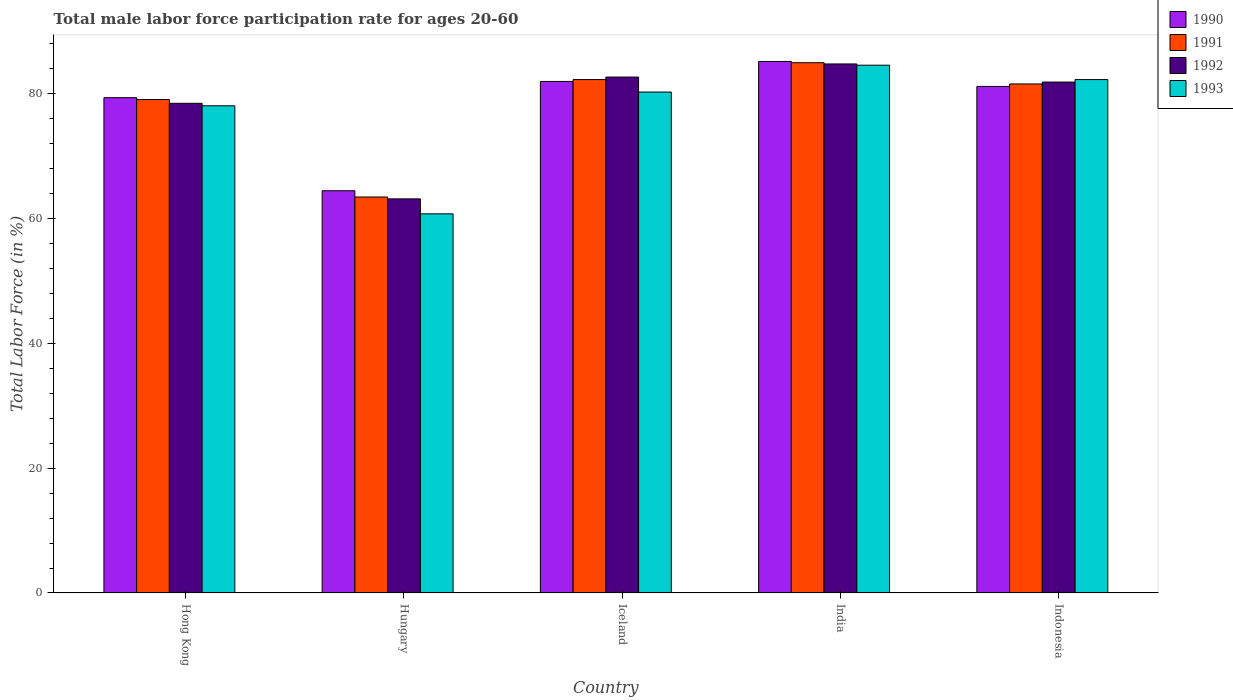How many groups of bars are there?
Keep it short and to the point. 5. Are the number of bars on each tick of the X-axis equal?
Keep it short and to the point. Yes. What is the label of the 3rd group of bars from the left?
Offer a terse response. Iceland. In how many cases, is the number of bars for a given country not equal to the number of legend labels?
Offer a very short reply. 0. What is the male labor force participation rate in 1992 in Hong Kong?
Offer a very short reply. 78.4. Across all countries, what is the maximum male labor force participation rate in 1993?
Make the answer very short. 84.5. Across all countries, what is the minimum male labor force participation rate in 1991?
Offer a very short reply. 63.4. In which country was the male labor force participation rate in 1992 maximum?
Your response must be concise. India. In which country was the male labor force participation rate in 1993 minimum?
Offer a terse response. Hungary. What is the total male labor force participation rate in 1990 in the graph?
Keep it short and to the point. 391.8. What is the difference between the male labor force participation rate in 1991 in Hungary and that in Indonesia?
Provide a short and direct response. -18.1. What is the difference between the male labor force participation rate in 1990 in India and the male labor force participation rate in 1991 in Indonesia?
Provide a short and direct response. 3.6. What is the average male labor force participation rate in 1991 per country?
Make the answer very short. 78.2. What is the difference between the male labor force participation rate of/in 1991 and male labor force participation rate of/in 1993 in Indonesia?
Keep it short and to the point. -0.7. In how many countries, is the male labor force participation rate in 1990 greater than 80 %?
Your answer should be compact. 3. What is the ratio of the male labor force participation rate in 1993 in India to that in Indonesia?
Offer a terse response. 1.03. Is the male labor force participation rate in 1991 in Hungary less than that in Indonesia?
Your answer should be compact. Yes. Is the difference between the male labor force participation rate in 1991 in Hong Kong and Indonesia greater than the difference between the male labor force participation rate in 1993 in Hong Kong and Indonesia?
Your answer should be compact. Yes. What is the difference between the highest and the second highest male labor force participation rate in 1992?
Provide a short and direct response. -0.8. What is the difference between the highest and the lowest male labor force participation rate in 1992?
Give a very brief answer. 21.6. Is the sum of the male labor force participation rate in 1991 in India and Indonesia greater than the maximum male labor force participation rate in 1992 across all countries?
Make the answer very short. Yes. What does the 4th bar from the left in Iceland represents?
Provide a short and direct response. 1993. What does the 4th bar from the right in Hong Kong represents?
Your response must be concise. 1990. Is it the case that in every country, the sum of the male labor force participation rate in 1991 and male labor force participation rate in 1993 is greater than the male labor force participation rate in 1990?
Your answer should be very brief. Yes. How many bars are there?
Your response must be concise. 20. Are the values on the major ticks of Y-axis written in scientific E-notation?
Offer a very short reply. No. Does the graph contain any zero values?
Your answer should be very brief. No. Does the graph contain grids?
Keep it short and to the point. No. How are the legend labels stacked?
Keep it short and to the point. Vertical. What is the title of the graph?
Your response must be concise. Total male labor force participation rate for ages 20-60. Does "1983" appear as one of the legend labels in the graph?
Your answer should be compact. No. What is the Total Labor Force (in %) of 1990 in Hong Kong?
Offer a terse response. 79.3. What is the Total Labor Force (in %) of 1991 in Hong Kong?
Ensure brevity in your answer.  79. What is the Total Labor Force (in %) in 1992 in Hong Kong?
Give a very brief answer. 78.4. What is the Total Labor Force (in %) in 1990 in Hungary?
Ensure brevity in your answer.  64.4. What is the Total Labor Force (in %) in 1991 in Hungary?
Make the answer very short. 63.4. What is the Total Labor Force (in %) of 1992 in Hungary?
Provide a succinct answer. 63.1. What is the Total Labor Force (in %) of 1993 in Hungary?
Provide a succinct answer. 60.7. What is the Total Labor Force (in %) in 1990 in Iceland?
Your answer should be very brief. 81.9. What is the Total Labor Force (in %) of 1991 in Iceland?
Make the answer very short. 82.2. What is the Total Labor Force (in %) in 1992 in Iceland?
Ensure brevity in your answer.  82.6. What is the Total Labor Force (in %) in 1993 in Iceland?
Offer a terse response. 80.2. What is the Total Labor Force (in %) in 1990 in India?
Keep it short and to the point. 85.1. What is the Total Labor Force (in %) of 1991 in India?
Provide a succinct answer. 84.9. What is the Total Labor Force (in %) in 1992 in India?
Ensure brevity in your answer.  84.7. What is the Total Labor Force (in %) of 1993 in India?
Your response must be concise. 84.5. What is the Total Labor Force (in %) of 1990 in Indonesia?
Your response must be concise. 81.1. What is the Total Labor Force (in %) of 1991 in Indonesia?
Give a very brief answer. 81.5. What is the Total Labor Force (in %) in 1992 in Indonesia?
Make the answer very short. 81.8. What is the Total Labor Force (in %) of 1993 in Indonesia?
Offer a very short reply. 82.2. Across all countries, what is the maximum Total Labor Force (in %) in 1990?
Provide a short and direct response. 85.1. Across all countries, what is the maximum Total Labor Force (in %) of 1991?
Give a very brief answer. 84.9. Across all countries, what is the maximum Total Labor Force (in %) of 1992?
Your response must be concise. 84.7. Across all countries, what is the maximum Total Labor Force (in %) in 1993?
Your answer should be compact. 84.5. Across all countries, what is the minimum Total Labor Force (in %) in 1990?
Make the answer very short. 64.4. Across all countries, what is the minimum Total Labor Force (in %) in 1991?
Your response must be concise. 63.4. Across all countries, what is the minimum Total Labor Force (in %) in 1992?
Provide a short and direct response. 63.1. Across all countries, what is the minimum Total Labor Force (in %) in 1993?
Make the answer very short. 60.7. What is the total Total Labor Force (in %) in 1990 in the graph?
Your response must be concise. 391.8. What is the total Total Labor Force (in %) in 1991 in the graph?
Provide a succinct answer. 391. What is the total Total Labor Force (in %) of 1992 in the graph?
Give a very brief answer. 390.6. What is the total Total Labor Force (in %) in 1993 in the graph?
Your response must be concise. 385.6. What is the difference between the Total Labor Force (in %) in 1990 in Hong Kong and that in Hungary?
Ensure brevity in your answer.  14.9. What is the difference between the Total Labor Force (in %) in 1992 in Hong Kong and that in Hungary?
Offer a terse response. 15.3. What is the difference between the Total Labor Force (in %) of 1991 in Hong Kong and that in Iceland?
Offer a terse response. -3.2. What is the difference between the Total Labor Force (in %) of 1992 in Hong Kong and that in Iceland?
Your answer should be compact. -4.2. What is the difference between the Total Labor Force (in %) in 1993 in Hong Kong and that in Iceland?
Your answer should be very brief. -2.2. What is the difference between the Total Labor Force (in %) of 1993 in Hong Kong and that in India?
Make the answer very short. -6.5. What is the difference between the Total Labor Force (in %) of 1990 in Hong Kong and that in Indonesia?
Offer a very short reply. -1.8. What is the difference between the Total Labor Force (in %) of 1992 in Hong Kong and that in Indonesia?
Keep it short and to the point. -3.4. What is the difference between the Total Labor Force (in %) in 1990 in Hungary and that in Iceland?
Your answer should be compact. -17.5. What is the difference between the Total Labor Force (in %) of 1991 in Hungary and that in Iceland?
Offer a terse response. -18.8. What is the difference between the Total Labor Force (in %) of 1992 in Hungary and that in Iceland?
Your answer should be very brief. -19.5. What is the difference between the Total Labor Force (in %) in 1993 in Hungary and that in Iceland?
Provide a short and direct response. -19.5. What is the difference between the Total Labor Force (in %) in 1990 in Hungary and that in India?
Your answer should be very brief. -20.7. What is the difference between the Total Labor Force (in %) of 1991 in Hungary and that in India?
Your answer should be compact. -21.5. What is the difference between the Total Labor Force (in %) of 1992 in Hungary and that in India?
Keep it short and to the point. -21.6. What is the difference between the Total Labor Force (in %) of 1993 in Hungary and that in India?
Your answer should be very brief. -23.8. What is the difference between the Total Labor Force (in %) of 1990 in Hungary and that in Indonesia?
Provide a succinct answer. -16.7. What is the difference between the Total Labor Force (in %) in 1991 in Hungary and that in Indonesia?
Provide a succinct answer. -18.1. What is the difference between the Total Labor Force (in %) of 1992 in Hungary and that in Indonesia?
Your answer should be compact. -18.7. What is the difference between the Total Labor Force (in %) of 1993 in Hungary and that in Indonesia?
Make the answer very short. -21.5. What is the difference between the Total Labor Force (in %) of 1991 in Iceland and that in India?
Your answer should be very brief. -2.7. What is the difference between the Total Labor Force (in %) of 1993 in Iceland and that in India?
Ensure brevity in your answer.  -4.3. What is the difference between the Total Labor Force (in %) in 1990 in Iceland and that in Indonesia?
Provide a succinct answer. 0.8. What is the difference between the Total Labor Force (in %) of 1992 in Iceland and that in Indonesia?
Ensure brevity in your answer.  0.8. What is the difference between the Total Labor Force (in %) in 1991 in India and that in Indonesia?
Your answer should be compact. 3.4. What is the difference between the Total Labor Force (in %) in 1992 in India and that in Indonesia?
Offer a very short reply. 2.9. What is the difference between the Total Labor Force (in %) in 1993 in India and that in Indonesia?
Your answer should be compact. 2.3. What is the difference between the Total Labor Force (in %) in 1990 in Hong Kong and the Total Labor Force (in %) in 1991 in Hungary?
Your answer should be very brief. 15.9. What is the difference between the Total Labor Force (in %) of 1990 in Hong Kong and the Total Labor Force (in %) of 1992 in Hungary?
Your response must be concise. 16.2. What is the difference between the Total Labor Force (in %) of 1990 in Hong Kong and the Total Labor Force (in %) of 1992 in Iceland?
Ensure brevity in your answer.  -3.3. What is the difference between the Total Labor Force (in %) in 1990 in Hong Kong and the Total Labor Force (in %) in 1993 in Iceland?
Make the answer very short. -0.9. What is the difference between the Total Labor Force (in %) of 1990 in Hong Kong and the Total Labor Force (in %) of 1991 in India?
Ensure brevity in your answer.  -5.6. What is the difference between the Total Labor Force (in %) of 1991 in Hong Kong and the Total Labor Force (in %) of 1992 in India?
Ensure brevity in your answer.  -5.7. What is the difference between the Total Labor Force (in %) in 1991 in Hong Kong and the Total Labor Force (in %) in 1993 in India?
Keep it short and to the point. -5.5. What is the difference between the Total Labor Force (in %) in 1990 in Hong Kong and the Total Labor Force (in %) in 1993 in Indonesia?
Your answer should be compact. -2.9. What is the difference between the Total Labor Force (in %) in 1990 in Hungary and the Total Labor Force (in %) in 1991 in Iceland?
Offer a very short reply. -17.8. What is the difference between the Total Labor Force (in %) of 1990 in Hungary and the Total Labor Force (in %) of 1992 in Iceland?
Your answer should be compact. -18.2. What is the difference between the Total Labor Force (in %) of 1990 in Hungary and the Total Labor Force (in %) of 1993 in Iceland?
Ensure brevity in your answer.  -15.8. What is the difference between the Total Labor Force (in %) in 1991 in Hungary and the Total Labor Force (in %) in 1992 in Iceland?
Ensure brevity in your answer.  -19.2. What is the difference between the Total Labor Force (in %) of 1991 in Hungary and the Total Labor Force (in %) of 1993 in Iceland?
Provide a succinct answer. -16.8. What is the difference between the Total Labor Force (in %) in 1992 in Hungary and the Total Labor Force (in %) in 1993 in Iceland?
Offer a very short reply. -17.1. What is the difference between the Total Labor Force (in %) of 1990 in Hungary and the Total Labor Force (in %) of 1991 in India?
Your response must be concise. -20.5. What is the difference between the Total Labor Force (in %) in 1990 in Hungary and the Total Labor Force (in %) in 1992 in India?
Make the answer very short. -20.3. What is the difference between the Total Labor Force (in %) of 1990 in Hungary and the Total Labor Force (in %) of 1993 in India?
Keep it short and to the point. -20.1. What is the difference between the Total Labor Force (in %) in 1991 in Hungary and the Total Labor Force (in %) in 1992 in India?
Offer a terse response. -21.3. What is the difference between the Total Labor Force (in %) in 1991 in Hungary and the Total Labor Force (in %) in 1993 in India?
Ensure brevity in your answer.  -21.1. What is the difference between the Total Labor Force (in %) in 1992 in Hungary and the Total Labor Force (in %) in 1993 in India?
Make the answer very short. -21.4. What is the difference between the Total Labor Force (in %) of 1990 in Hungary and the Total Labor Force (in %) of 1991 in Indonesia?
Give a very brief answer. -17.1. What is the difference between the Total Labor Force (in %) of 1990 in Hungary and the Total Labor Force (in %) of 1992 in Indonesia?
Keep it short and to the point. -17.4. What is the difference between the Total Labor Force (in %) of 1990 in Hungary and the Total Labor Force (in %) of 1993 in Indonesia?
Ensure brevity in your answer.  -17.8. What is the difference between the Total Labor Force (in %) of 1991 in Hungary and the Total Labor Force (in %) of 1992 in Indonesia?
Give a very brief answer. -18.4. What is the difference between the Total Labor Force (in %) of 1991 in Hungary and the Total Labor Force (in %) of 1993 in Indonesia?
Keep it short and to the point. -18.8. What is the difference between the Total Labor Force (in %) of 1992 in Hungary and the Total Labor Force (in %) of 1993 in Indonesia?
Ensure brevity in your answer.  -19.1. What is the difference between the Total Labor Force (in %) of 1990 in Iceland and the Total Labor Force (in %) of 1991 in India?
Provide a short and direct response. -3. What is the difference between the Total Labor Force (in %) in 1990 in Iceland and the Total Labor Force (in %) in 1992 in India?
Offer a very short reply. -2.8. What is the difference between the Total Labor Force (in %) in 1990 in Iceland and the Total Labor Force (in %) in 1993 in India?
Ensure brevity in your answer.  -2.6. What is the difference between the Total Labor Force (in %) of 1991 in Iceland and the Total Labor Force (in %) of 1992 in India?
Offer a terse response. -2.5. What is the difference between the Total Labor Force (in %) of 1990 in Iceland and the Total Labor Force (in %) of 1991 in Indonesia?
Ensure brevity in your answer.  0.4. What is the difference between the Total Labor Force (in %) of 1990 in Iceland and the Total Labor Force (in %) of 1993 in Indonesia?
Make the answer very short. -0.3. What is the difference between the Total Labor Force (in %) in 1991 in Iceland and the Total Labor Force (in %) in 1992 in Indonesia?
Give a very brief answer. 0.4. What is the difference between the Total Labor Force (in %) of 1991 in Iceland and the Total Labor Force (in %) of 1993 in Indonesia?
Provide a succinct answer. 0. What is the difference between the Total Labor Force (in %) in 1992 in Iceland and the Total Labor Force (in %) in 1993 in Indonesia?
Ensure brevity in your answer.  0.4. What is the difference between the Total Labor Force (in %) in 1990 in India and the Total Labor Force (in %) in 1991 in Indonesia?
Give a very brief answer. 3.6. What is the difference between the Total Labor Force (in %) of 1990 in India and the Total Labor Force (in %) of 1992 in Indonesia?
Give a very brief answer. 3.3. What is the difference between the Total Labor Force (in %) in 1991 in India and the Total Labor Force (in %) in 1993 in Indonesia?
Ensure brevity in your answer.  2.7. What is the difference between the Total Labor Force (in %) in 1992 in India and the Total Labor Force (in %) in 1993 in Indonesia?
Ensure brevity in your answer.  2.5. What is the average Total Labor Force (in %) of 1990 per country?
Offer a very short reply. 78.36. What is the average Total Labor Force (in %) in 1991 per country?
Keep it short and to the point. 78.2. What is the average Total Labor Force (in %) in 1992 per country?
Keep it short and to the point. 78.12. What is the average Total Labor Force (in %) in 1993 per country?
Keep it short and to the point. 77.12. What is the difference between the Total Labor Force (in %) of 1990 and Total Labor Force (in %) of 1992 in Hong Kong?
Your response must be concise. 0.9. What is the difference between the Total Labor Force (in %) in 1990 and Total Labor Force (in %) in 1993 in Hong Kong?
Your answer should be compact. 1.3. What is the difference between the Total Labor Force (in %) in 1991 and Total Labor Force (in %) in 1992 in Hong Kong?
Provide a succinct answer. 0.6. What is the difference between the Total Labor Force (in %) of 1990 and Total Labor Force (in %) of 1993 in Hungary?
Your answer should be very brief. 3.7. What is the difference between the Total Labor Force (in %) of 1991 and Total Labor Force (in %) of 1993 in Hungary?
Offer a terse response. 2.7. What is the difference between the Total Labor Force (in %) of 1990 and Total Labor Force (in %) of 1991 in Iceland?
Offer a terse response. -0.3. What is the difference between the Total Labor Force (in %) in 1990 and Total Labor Force (in %) in 1992 in Iceland?
Your response must be concise. -0.7. What is the difference between the Total Labor Force (in %) of 1990 and Total Labor Force (in %) of 1991 in India?
Keep it short and to the point. 0.2. What is the difference between the Total Labor Force (in %) in 1990 and Total Labor Force (in %) in 1992 in India?
Keep it short and to the point. 0.4. What is the difference between the Total Labor Force (in %) of 1991 and Total Labor Force (in %) of 1993 in India?
Your response must be concise. 0.4. What is the difference between the Total Labor Force (in %) in 1990 and Total Labor Force (in %) in 1991 in Indonesia?
Provide a succinct answer. -0.4. What is the difference between the Total Labor Force (in %) in 1992 and Total Labor Force (in %) in 1993 in Indonesia?
Your response must be concise. -0.4. What is the ratio of the Total Labor Force (in %) in 1990 in Hong Kong to that in Hungary?
Ensure brevity in your answer.  1.23. What is the ratio of the Total Labor Force (in %) in 1991 in Hong Kong to that in Hungary?
Provide a short and direct response. 1.25. What is the ratio of the Total Labor Force (in %) in 1992 in Hong Kong to that in Hungary?
Give a very brief answer. 1.24. What is the ratio of the Total Labor Force (in %) of 1993 in Hong Kong to that in Hungary?
Offer a very short reply. 1.28. What is the ratio of the Total Labor Force (in %) in 1990 in Hong Kong to that in Iceland?
Make the answer very short. 0.97. What is the ratio of the Total Labor Force (in %) in 1991 in Hong Kong to that in Iceland?
Keep it short and to the point. 0.96. What is the ratio of the Total Labor Force (in %) in 1992 in Hong Kong to that in Iceland?
Offer a terse response. 0.95. What is the ratio of the Total Labor Force (in %) in 1993 in Hong Kong to that in Iceland?
Offer a very short reply. 0.97. What is the ratio of the Total Labor Force (in %) of 1990 in Hong Kong to that in India?
Your answer should be compact. 0.93. What is the ratio of the Total Labor Force (in %) of 1991 in Hong Kong to that in India?
Offer a very short reply. 0.93. What is the ratio of the Total Labor Force (in %) of 1992 in Hong Kong to that in India?
Offer a terse response. 0.93. What is the ratio of the Total Labor Force (in %) in 1990 in Hong Kong to that in Indonesia?
Your answer should be very brief. 0.98. What is the ratio of the Total Labor Force (in %) of 1991 in Hong Kong to that in Indonesia?
Give a very brief answer. 0.97. What is the ratio of the Total Labor Force (in %) of 1992 in Hong Kong to that in Indonesia?
Offer a terse response. 0.96. What is the ratio of the Total Labor Force (in %) of 1993 in Hong Kong to that in Indonesia?
Offer a terse response. 0.95. What is the ratio of the Total Labor Force (in %) in 1990 in Hungary to that in Iceland?
Your answer should be compact. 0.79. What is the ratio of the Total Labor Force (in %) in 1991 in Hungary to that in Iceland?
Your response must be concise. 0.77. What is the ratio of the Total Labor Force (in %) in 1992 in Hungary to that in Iceland?
Provide a short and direct response. 0.76. What is the ratio of the Total Labor Force (in %) of 1993 in Hungary to that in Iceland?
Your answer should be very brief. 0.76. What is the ratio of the Total Labor Force (in %) in 1990 in Hungary to that in India?
Your answer should be very brief. 0.76. What is the ratio of the Total Labor Force (in %) in 1991 in Hungary to that in India?
Your answer should be very brief. 0.75. What is the ratio of the Total Labor Force (in %) of 1992 in Hungary to that in India?
Provide a short and direct response. 0.74. What is the ratio of the Total Labor Force (in %) in 1993 in Hungary to that in India?
Your answer should be compact. 0.72. What is the ratio of the Total Labor Force (in %) in 1990 in Hungary to that in Indonesia?
Offer a terse response. 0.79. What is the ratio of the Total Labor Force (in %) in 1991 in Hungary to that in Indonesia?
Your response must be concise. 0.78. What is the ratio of the Total Labor Force (in %) of 1992 in Hungary to that in Indonesia?
Ensure brevity in your answer.  0.77. What is the ratio of the Total Labor Force (in %) in 1993 in Hungary to that in Indonesia?
Keep it short and to the point. 0.74. What is the ratio of the Total Labor Force (in %) in 1990 in Iceland to that in India?
Give a very brief answer. 0.96. What is the ratio of the Total Labor Force (in %) of 1991 in Iceland to that in India?
Ensure brevity in your answer.  0.97. What is the ratio of the Total Labor Force (in %) in 1992 in Iceland to that in India?
Keep it short and to the point. 0.98. What is the ratio of the Total Labor Force (in %) in 1993 in Iceland to that in India?
Make the answer very short. 0.95. What is the ratio of the Total Labor Force (in %) in 1990 in Iceland to that in Indonesia?
Your answer should be very brief. 1.01. What is the ratio of the Total Labor Force (in %) of 1991 in Iceland to that in Indonesia?
Give a very brief answer. 1.01. What is the ratio of the Total Labor Force (in %) of 1992 in Iceland to that in Indonesia?
Provide a succinct answer. 1.01. What is the ratio of the Total Labor Force (in %) in 1993 in Iceland to that in Indonesia?
Your answer should be very brief. 0.98. What is the ratio of the Total Labor Force (in %) in 1990 in India to that in Indonesia?
Keep it short and to the point. 1.05. What is the ratio of the Total Labor Force (in %) in 1991 in India to that in Indonesia?
Your response must be concise. 1.04. What is the ratio of the Total Labor Force (in %) of 1992 in India to that in Indonesia?
Keep it short and to the point. 1.04. What is the ratio of the Total Labor Force (in %) in 1993 in India to that in Indonesia?
Provide a short and direct response. 1.03. What is the difference between the highest and the second highest Total Labor Force (in %) in 1992?
Your answer should be very brief. 2.1. What is the difference between the highest and the second highest Total Labor Force (in %) of 1993?
Offer a very short reply. 2.3. What is the difference between the highest and the lowest Total Labor Force (in %) of 1990?
Offer a very short reply. 20.7. What is the difference between the highest and the lowest Total Labor Force (in %) in 1991?
Offer a very short reply. 21.5. What is the difference between the highest and the lowest Total Labor Force (in %) of 1992?
Your answer should be compact. 21.6. What is the difference between the highest and the lowest Total Labor Force (in %) of 1993?
Ensure brevity in your answer.  23.8. 